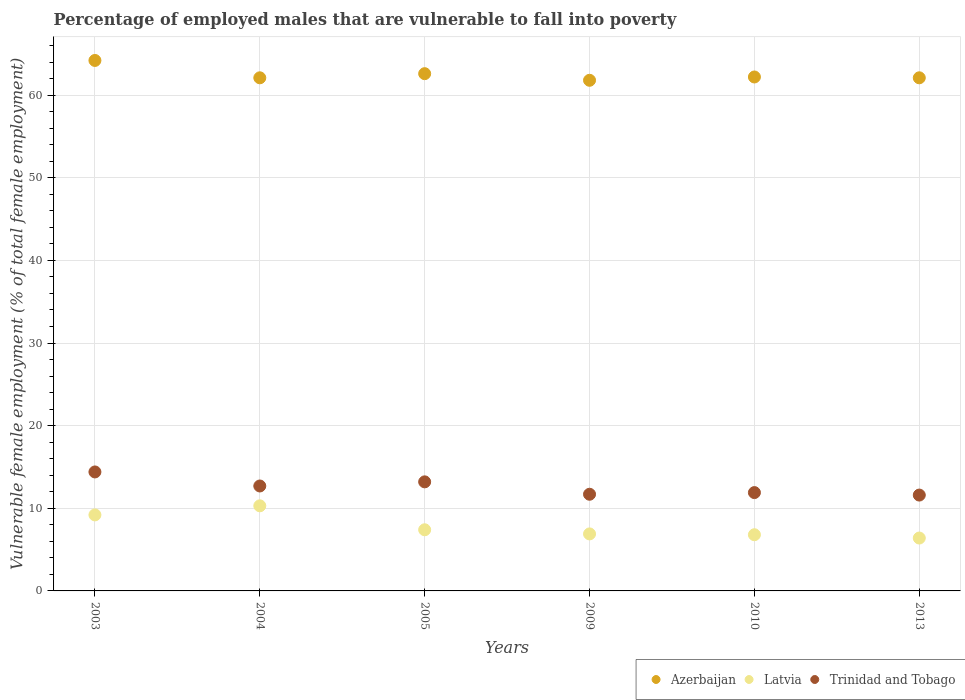How many different coloured dotlines are there?
Make the answer very short. 3. What is the percentage of employed males who are vulnerable to fall into poverty in Trinidad and Tobago in 2003?
Give a very brief answer. 14.4. Across all years, what is the maximum percentage of employed males who are vulnerable to fall into poverty in Azerbaijan?
Your answer should be compact. 64.2. Across all years, what is the minimum percentage of employed males who are vulnerable to fall into poverty in Trinidad and Tobago?
Offer a very short reply. 11.6. In which year was the percentage of employed males who are vulnerable to fall into poverty in Latvia maximum?
Your response must be concise. 2004. What is the total percentage of employed males who are vulnerable to fall into poverty in Latvia in the graph?
Your answer should be very brief. 47. What is the difference between the percentage of employed males who are vulnerable to fall into poverty in Trinidad and Tobago in 2009 and that in 2013?
Your answer should be compact. 0.1. What is the difference between the percentage of employed males who are vulnerable to fall into poverty in Latvia in 2004 and the percentage of employed males who are vulnerable to fall into poverty in Trinidad and Tobago in 2013?
Your response must be concise. -1.3. What is the average percentage of employed males who are vulnerable to fall into poverty in Azerbaijan per year?
Give a very brief answer. 62.5. In the year 2010, what is the difference between the percentage of employed males who are vulnerable to fall into poverty in Trinidad and Tobago and percentage of employed males who are vulnerable to fall into poverty in Azerbaijan?
Your answer should be very brief. -50.3. In how many years, is the percentage of employed males who are vulnerable to fall into poverty in Azerbaijan greater than 10 %?
Offer a terse response. 6. What is the ratio of the percentage of employed males who are vulnerable to fall into poverty in Latvia in 2005 to that in 2013?
Offer a terse response. 1.16. Is the difference between the percentage of employed males who are vulnerable to fall into poverty in Trinidad and Tobago in 2009 and 2013 greater than the difference between the percentage of employed males who are vulnerable to fall into poverty in Azerbaijan in 2009 and 2013?
Ensure brevity in your answer.  Yes. What is the difference between the highest and the second highest percentage of employed males who are vulnerable to fall into poverty in Latvia?
Make the answer very short. 1.1. What is the difference between the highest and the lowest percentage of employed males who are vulnerable to fall into poverty in Latvia?
Keep it short and to the point. 3.9. Is the sum of the percentage of employed males who are vulnerable to fall into poverty in Trinidad and Tobago in 2004 and 2009 greater than the maximum percentage of employed males who are vulnerable to fall into poverty in Latvia across all years?
Offer a very short reply. Yes. Is it the case that in every year, the sum of the percentage of employed males who are vulnerable to fall into poverty in Azerbaijan and percentage of employed males who are vulnerable to fall into poverty in Latvia  is greater than the percentage of employed males who are vulnerable to fall into poverty in Trinidad and Tobago?
Make the answer very short. Yes. Does the percentage of employed males who are vulnerable to fall into poverty in Latvia monotonically increase over the years?
Provide a succinct answer. No. Is the percentage of employed males who are vulnerable to fall into poverty in Trinidad and Tobago strictly greater than the percentage of employed males who are vulnerable to fall into poverty in Azerbaijan over the years?
Offer a very short reply. No. How many dotlines are there?
Offer a very short reply. 3. What is the difference between two consecutive major ticks on the Y-axis?
Give a very brief answer. 10. Does the graph contain any zero values?
Make the answer very short. No. Does the graph contain grids?
Offer a very short reply. Yes. What is the title of the graph?
Your answer should be very brief. Percentage of employed males that are vulnerable to fall into poverty. Does "East Asia (all income levels)" appear as one of the legend labels in the graph?
Provide a succinct answer. No. What is the label or title of the X-axis?
Offer a terse response. Years. What is the label or title of the Y-axis?
Offer a very short reply. Vulnerable female employment (% of total female employment). What is the Vulnerable female employment (% of total female employment) in Azerbaijan in 2003?
Provide a succinct answer. 64.2. What is the Vulnerable female employment (% of total female employment) of Latvia in 2003?
Provide a succinct answer. 9.2. What is the Vulnerable female employment (% of total female employment) in Trinidad and Tobago in 2003?
Your answer should be compact. 14.4. What is the Vulnerable female employment (% of total female employment) of Azerbaijan in 2004?
Your answer should be compact. 62.1. What is the Vulnerable female employment (% of total female employment) of Latvia in 2004?
Ensure brevity in your answer.  10.3. What is the Vulnerable female employment (% of total female employment) in Trinidad and Tobago in 2004?
Offer a very short reply. 12.7. What is the Vulnerable female employment (% of total female employment) in Azerbaijan in 2005?
Offer a very short reply. 62.6. What is the Vulnerable female employment (% of total female employment) in Latvia in 2005?
Keep it short and to the point. 7.4. What is the Vulnerable female employment (% of total female employment) in Trinidad and Tobago in 2005?
Make the answer very short. 13.2. What is the Vulnerable female employment (% of total female employment) in Azerbaijan in 2009?
Give a very brief answer. 61.8. What is the Vulnerable female employment (% of total female employment) of Latvia in 2009?
Offer a terse response. 6.9. What is the Vulnerable female employment (% of total female employment) of Trinidad and Tobago in 2009?
Provide a short and direct response. 11.7. What is the Vulnerable female employment (% of total female employment) of Azerbaijan in 2010?
Provide a short and direct response. 62.2. What is the Vulnerable female employment (% of total female employment) of Latvia in 2010?
Give a very brief answer. 6.8. What is the Vulnerable female employment (% of total female employment) in Trinidad and Tobago in 2010?
Your answer should be compact. 11.9. What is the Vulnerable female employment (% of total female employment) in Azerbaijan in 2013?
Ensure brevity in your answer.  62.1. What is the Vulnerable female employment (% of total female employment) in Latvia in 2013?
Offer a terse response. 6.4. What is the Vulnerable female employment (% of total female employment) in Trinidad and Tobago in 2013?
Provide a short and direct response. 11.6. Across all years, what is the maximum Vulnerable female employment (% of total female employment) in Azerbaijan?
Offer a terse response. 64.2. Across all years, what is the maximum Vulnerable female employment (% of total female employment) in Latvia?
Your answer should be very brief. 10.3. Across all years, what is the maximum Vulnerable female employment (% of total female employment) of Trinidad and Tobago?
Provide a short and direct response. 14.4. Across all years, what is the minimum Vulnerable female employment (% of total female employment) of Azerbaijan?
Give a very brief answer. 61.8. Across all years, what is the minimum Vulnerable female employment (% of total female employment) in Latvia?
Your answer should be very brief. 6.4. Across all years, what is the minimum Vulnerable female employment (% of total female employment) in Trinidad and Tobago?
Offer a terse response. 11.6. What is the total Vulnerable female employment (% of total female employment) of Azerbaijan in the graph?
Your answer should be very brief. 375. What is the total Vulnerable female employment (% of total female employment) of Trinidad and Tobago in the graph?
Offer a terse response. 75.5. What is the difference between the Vulnerable female employment (% of total female employment) of Latvia in 2003 and that in 2004?
Give a very brief answer. -1.1. What is the difference between the Vulnerable female employment (% of total female employment) in Azerbaijan in 2003 and that in 2005?
Give a very brief answer. 1.6. What is the difference between the Vulnerable female employment (% of total female employment) of Latvia in 2003 and that in 2009?
Keep it short and to the point. 2.3. What is the difference between the Vulnerable female employment (% of total female employment) of Azerbaijan in 2003 and that in 2010?
Offer a terse response. 2. What is the difference between the Vulnerable female employment (% of total female employment) in Latvia in 2003 and that in 2010?
Your answer should be very brief. 2.4. What is the difference between the Vulnerable female employment (% of total female employment) of Trinidad and Tobago in 2003 and that in 2010?
Provide a succinct answer. 2.5. What is the difference between the Vulnerable female employment (% of total female employment) of Azerbaijan in 2003 and that in 2013?
Keep it short and to the point. 2.1. What is the difference between the Vulnerable female employment (% of total female employment) of Latvia in 2003 and that in 2013?
Make the answer very short. 2.8. What is the difference between the Vulnerable female employment (% of total female employment) of Azerbaijan in 2004 and that in 2005?
Your response must be concise. -0.5. What is the difference between the Vulnerable female employment (% of total female employment) in Azerbaijan in 2004 and that in 2009?
Your answer should be very brief. 0.3. What is the difference between the Vulnerable female employment (% of total female employment) of Latvia in 2004 and that in 2009?
Make the answer very short. 3.4. What is the difference between the Vulnerable female employment (% of total female employment) in Trinidad and Tobago in 2004 and that in 2009?
Ensure brevity in your answer.  1. What is the difference between the Vulnerable female employment (% of total female employment) in Azerbaijan in 2004 and that in 2010?
Make the answer very short. -0.1. What is the difference between the Vulnerable female employment (% of total female employment) in Azerbaijan in 2004 and that in 2013?
Ensure brevity in your answer.  0. What is the difference between the Vulnerable female employment (% of total female employment) in Latvia in 2004 and that in 2013?
Offer a very short reply. 3.9. What is the difference between the Vulnerable female employment (% of total female employment) of Latvia in 2005 and that in 2010?
Ensure brevity in your answer.  0.6. What is the difference between the Vulnerable female employment (% of total female employment) of Latvia in 2005 and that in 2013?
Offer a terse response. 1. What is the difference between the Vulnerable female employment (% of total female employment) in Azerbaijan in 2009 and that in 2010?
Your answer should be compact. -0.4. What is the difference between the Vulnerable female employment (% of total female employment) in Trinidad and Tobago in 2009 and that in 2010?
Make the answer very short. -0.2. What is the difference between the Vulnerable female employment (% of total female employment) of Latvia in 2009 and that in 2013?
Provide a short and direct response. 0.5. What is the difference between the Vulnerable female employment (% of total female employment) of Trinidad and Tobago in 2009 and that in 2013?
Your response must be concise. 0.1. What is the difference between the Vulnerable female employment (% of total female employment) in Latvia in 2010 and that in 2013?
Your answer should be compact. 0.4. What is the difference between the Vulnerable female employment (% of total female employment) of Trinidad and Tobago in 2010 and that in 2013?
Make the answer very short. 0.3. What is the difference between the Vulnerable female employment (% of total female employment) in Azerbaijan in 2003 and the Vulnerable female employment (% of total female employment) in Latvia in 2004?
Keep it short and to the point. 53.9. What is the difference between the Vulnerable female employment (% of total female employment) in Azerbaijan in 2003 and the Vulnerable female employment (% of total female employment) in Trinidad and Tobago in 2004?
Make the answer very short. 51.5. What is the difference between the Vulnerable female employment (% of total female employment) in Latvia in 2003 and the Vulnerable female employment (% of total female employment) in Trinidad and Tobago in 2004?
Ensure brevity in your answer.  -3.5. What is the difference between the Vulnerable female employment (% of total female employment) in Azerbaijan in 2003 and the Vulnerable female employment (% of total female employment) in Latvia in 2005?
Make the answer very short. 56.8. What is the difference between the Vulnerable female employment (% of total female employment) in Azerbaijan in 2003 and the Vulnerable female employment (% of total female employment) in Latvia in 2009?
Keep it short and to the point. 57.3. What is the difference between the Vulnerable female employment (% of total female employment) in Azerbaijan in 2003 and the Vulnerable female employment (% of total female employment) in Trinidad and Tobago in 2009?
Ensure brevity in your answer.  52.5. What is the difference between the Vulnerable female employment (% of total female employment) in Azerbaijan in 2003 and the Vulnerable female employment (% of total female employment) in Latvia in 2010?
Provide a succinct answer. 57.4. What is the difference between the Vulnerable female employment (% of total female employment) in Azerbaijan in 2003 and the Vulnerable female employment (% of total female employment) in Trinidad and Tobago in 2010?
Make the answer very short. 52.3. What is the difference between the Vulnerable female employment (% of total female employment) of Latvia in 2003 and the Vulnerable female employment (% of total female employment) of Trinidad and Tobago in 2010?
Offer a very short reply. -2.7. What is the difference between the Vulnerable female employment (% of total female employment) in Azerbaijan in 2003 and the Vulnerable female employment (% of total female employment) in Latvia in 2013?
Make the answer very short. 57.8. What is the difference between the Vulnerable female employment (% of total female employment) of Azerbaijan in 2003 and the Vulnerable female employment (% of total female employment) of Trinidad and Tobago in 2013?
Offer a terse response. 52.6. What is the difference between the Vulnerable female employment (% of total female employment) of Latvia in 2003 and the Vulnerable female employment (% of total female employment) of Trinidad and Tobago in 2013?
Ensure brevity in your answer.  -2.4. What is the difference between the Vulnerable female employment (% of total female employment) of Azerbaijan in 2004 and the Vulnerable female employment (% of total female employment) of Latvia in 2005?
Provide a short and direct response. 54.7. What is the difference between the Vulnerable female employment (% of total female employment) of Azerbaijan in 2004 and the Vulnerable female employment (% of total female employment) of Trinidad and Tobago in 2005?
Your response must be concise. 48.9. What is the difference between the Vulnerable female employment (% of total female employment) of Azerbaijan in 2004 and the Vulnerable female employment (% of total female employment) of Latvia in 2009?
Your answer should be very brief. 55.2. What is the difference between the Vulnerable female employment (% of total female employment) in Azerbaijan in 2004 and the Vulnerable female employment (% of total female employment) in Trinidad and Tobago in 2009?
Offer a very short reply. 50.4. What is the difference between the Vulnerable female employment (% of total female employment) of Latvia in 2004 and the Vulnerable female employment (% of total female employment) of Trinidad and Tobago in 2009?
Keep it short and to the point. -1.4. What is the difference between the Vulnerable female employment (% of total female employment) of Azerbaijan in 2004 and the Vulnerable female employment (% of total female employment) of Latvia in 2010?
Provide a succinct answer. 55.3. What is the difference between the Vulnerable female employment (% of total female employment) of Azerbaijan in 2004 and the Vulnerable female employment (% of total female employment) of Trinidad and Tobago in 2010?
Ensure brevity in your answer.  50.2. What is the difference between the Vulnerable female employment (% of total female employment) of Latvia in 2004 and the Vulnerable female employment (% of total female employment) of Trinidad and Tobago in 2010?
Provide a short and direct response. -1.6. What is the difference between the Vulnerable female employment (% of total female employment) of Azerbaijan in 2004 and the Vulnerable female employment (% of total female employment) of Latvia in 2013?
Provide a short and direct response. 55.7. What is the difference between the Vulnerable female employment (% of total female employment) in Azerbaijan in 2004 and the Vulnerable female employment (% of total female employment) in Trinidad and Tobago in 2013?
Make the answer very short. 50.5. What is the difference between the Vulnerable female employment (% of total female employment) in Latvia in 2004 and the Vulnerable female employment (% of total female employment) in Trinidad and Tobago in 2013?
Provide a succinct answer. -1.3. What is the difference between the Vulnerable female employment (% of total female employment) of Azerbaijan in 2005 and the Vulnerable female employment (% of total female employment) of Latvia in 2009?
Your answer should be compact. 55.7. What is the difference between the Vulnerable female employment (% of total female employment) of Azerbaijan in 2005 and the Vulnerable female employment (% of total female employment) of Trinidad and Tobago in 2009?
Make the answer very short. 50.9. What is the difference between the Vulnerable female employment (% of total female employment) in Azerbaijan in 2005 and the Vulnerable female employment (% of total female employment) in Latvia in 2010?
Provide a short and direct response. 55.8. What is the difference between the Vulnerable female employment (% of total female employment) of Azerbaijan in 2005 and the Vulnerable female employment (% of total female employment) of Trinidad and Tobago in 2010?
Make the answer very short. 50.7. What is the difference between the Vulnerable female employment (% of total female employment) in Latvia in 2005 and the Vulnerable female employment (% of total female employment) in Trinidad and Tobago in 2010?
Make the answer very short. -4.5. What is the difference between the Vulnerable female employment (% of total female employment) in Azerbaijan in 2005 and the Vulnerable female employment (% of total female employment) in Latvia in 2013?
Keep it short and to the point. 56.2. What is the difference between the Vulnerable female employment (% of total female employment) in Latvia in 2005 and the Vulnerable female employment (% of total female employment) in Trinidad and Tobago in 2013?
Give a very brief answer. -4.2. What is the difference between the Vulnerable female employment (% of total female employment) of Azerbaijan in 2009 and the Vulnerable female employment (% of total female employment) of Trinidad and Tobago in 2010?
Make the answer very short. 49.9. What is the difference between the Vulnerable female employment (% of total female employment) of Azerbaijan in 2009 and the Vulnerable female employment (% of total female employment) of Latvia in 2013?
Your response must be concise. 55.4. What is the difference between the Vulnerable female employment (% of total female employment) in Azerbaijan in 2009 and the Vulnerable female employment (% of total female employment) in Trinidad and Tobago in 2013?
Ensure brevity in your answer.  50.2. What is the difference between the Vulnerable female employment (% of total female employment) of Azerbaijan in 2010 and the Vulnerable female employment (% of total female employment) of Latvia in 2013?
Ensure brevity in your answer.  55.8. What is the difference between the Vulnerable female employment (% of total female employment) in Azerbaijan in 2010 and the Vulnerable female employment (% of total female employment) in Trinidad and Tobago in 2013?
Keep it short and to the point. 50.6. What is the difference between the Vulnerable female employment (% of total female employment) of Latvia in 2010 and the Vulnerable female employment (% of total female employment) of Trinidad and Tobago in 2013?
Offer a terse response. -4.8. What is the average Vulnerable female employment (% of total female employment) in Azerbaijan per year?
Provide a succinct answer. 62.5. What is the average Vulnerable female employment (% of total female employment) in Latvia per year?
Make the answer very short. 7.83. What is the average Vulnerable female employment (% of total female employment) of Trinidad and Tobago per year?
Keep it short and to the point. 12.58. In the year 2003, what is the difference between the Vulnerable female employment (% of total female employment) in Azerbaijan and Vulnerable female employment (% of total female employment) in Trinidad and Tobago?
Offer a very short reply. 49.8. In the year 2004, what is the difference between the Vulnerable female employment (% of total female employment) of Azerbaijan and Vulnerable female employment (% of total female employment) of Latvia?
Ensure brevity in your answer.  51.8. In the year 2004, what is the difference between the Vulnerable female employment (% of total female employment) of Azerbaijan and Vulnerable female employment (% of total female employment) of Trinidad and Tobago?
Provide a short and direct response. 49.4. In the year 2005, what is the difference between the Vulnerable female employment (% of total female employment) in Azerbaijan and Vulnerable female employment (% of total female employment) in Latvia?
Provide a succinct answer. 55.2. In the year 2005, what is the difference between the Vulnerable female employment (% of total female employment) of Azerbaijan and Vulnerable female employment (% of total female employment) of Trinidad and Tobago?
Provide a short and direct response. 49.4. In the year 2005, what is the difference between the Vulnerable female employment (% of total female employment) in Latvia and Vulnerable female employment (% of total female employment) in Trinidad and Tobago?
Keep it short and to the point. -5.8. In the year 2009, what is the difference between the Vulnerable female employment (% of total female employment) in Azerbaijan and Vulnerable female employment (% of total female employment) in Latvia?
Provide a short and direct response. 54.9. In the year 2009, what is the difference between the Vulnerable female employment (% of total female employment) of Azerbaijan and Vulnerable female employment (% of total female employment) of Trinidad and Tobago?
Keep it short and to the point. 50.1. In the year 2010, what is the difference between the Vulnerable female employment (% of total female employment) of Azerbaijan and Vulnerable female employment (% of total female employment) of Latvia?
Your response must be concise. 55.4. In the year 2010, what is the difference between the Vulnerable female employment (% of total female employment) of Azerbaijan and Vulnerable female employment (% of total female employment) of Trinidad and Tobago?
Keep it short and to the point. 50.3. In the year 2010, what is the difference between the Vulnerable female employment (% of total female employment) of Latvia and Vulnerable female employment (% of total female employment) of Trinidad and Tobago?
Ensure brevity in your answer.  -5.1. In the year 2013, what is the difference between the Vulnerable female employment (% of total female employment) of Azerbaijan and Vulnerable female employment (% of total female employment) of Latvia?
Keep it short and to the point. 55.7. In the year 2013, what is the difference between the Vulnerable female employment (% of total female employment) of Azerbaijan and Vulnerable female employment (% of total female employment) of Trinidad and Tobago?
Your response must be concise. 50.5. In the year 2013, what is the difference between the Vulnerable female employment (% of total female employment) in Latvia and Vulnerable female employment (% of total female employment) in Trinidad and Tobago?
Ensure brevity in your answer.  -5.2. What is the ratio of the Vulnerable female employment (% of total female employment) of Azerbaijan in 2003 to that in 2004?
Keep it short and to the point. 1.03. What is the ratio of the Vulnerable female employment (% of total female employment) in Latvia in 2003 to that in 2004?
Offer a very short reply. 0.89. What is the ratio of the Vulnerable female employment (% of total female employment) in Trinidad and Tobago in 2003 to that in 2004?
Provide a succinct answer. 1.13. What is the ratio of the Vulnerable female employment (% of total female employment) of Azerbaijan in 2003 to that in 2005?
Offer a very short reply. 1.03. What is the ratio of the Vulnerable female employment (% of total female employment) in Latvia in 2003 to that in 2005?
Offer a very short reply. 1.24. What is the ratio of the Vulnerable female employment (% of total female employment) in Trinidad and Tobago in 2003 to that in 2005?
Your response must be concise. 1.09. What is the ratio of the Vulnerable female employment (% of total female employment) in Azerbaijan in 2003 to that in 2009?
Provide a short and direct response. 1.04. What is the ratio of the Vulnerable female employment (% of total female employment) in Latvia in 2003 to that in 2009?
Keep it short and to the point. 1.33. What is the ratio of the Vulnerable female employment (% of total female employment) of Trinidad and Tobago in 2003 to that in 2009?
Provide a succinct answer. 1.23. What is the ratio of the Vulnerable female employment (% of total female employment) in Azerbaijan in 2003 to that in 2010?
Offer a very short reply. 1.03. What is the ratio of the Vulnerable female employment (% of total female employment) in Latvia in 2003 to that in 2010?
Offer a very short reply. 1.35. What is the ratio of the Vulnerable female employment (% of total female employment) of Trinidad and Tobago in 2003 to that in 2010?
Offer a very short reply. 1.21. What is the ratio of the Vulnerable female employment (% of total female employment) of Azerbaijan in 2003 to that in 2013?
Your response must be concise. 1.03. What is the ratio of the Vulnerable female employment (% of total female employment) in Latvia in 2003 to that in 2013?
Provide a short and direct response. 1.44. What is the ratio of the Vulnerable female employment (% of total female employment) of Trinidad and Tobago in 2003 to that in 2013?
Provide a short and direct response. 1.24. What is the ratio of the Vulnerable female employment (% of total female employment) of Azerbaijan in 2004 to that in 2005?
Give a very brief answer. 0.99. What is the ratio of the Vulnerable female employment (% of total female employment) in Latvia in 2004 to that in 2005?
Keep it short and to the point. 1.39. What is the ratio of the Vulnerable female employment (% of total female employment) of Trinidad and Tobago in 2004 to that in 2005?
Make the answer very short. 0.96. What is the ratio of the Vulnerable female employment (% of total female employment) of Latvia in 2004 to that in 2009?
Your answer should be compact. 1.49. What is the ratio of the Vulnerable female employment (% of total female employment) in Trinidad and Tobago in 2004 to that in 2009?
Keep it short and to the point. 1.09. What is the ratio of the Vulnerable female employment (% of total female employment) in Latvia in 2004 to that in 2010?
Provide a short and direct response. 1.51. What is the ratio of the Vulnerable female employment (% of total female employment) of Trinidad and Tobago in 2004 to that in 2010?
Your response must be concise. 1.07. What is the ratio of the Vulnerable female employment (% of total female employment) of Latvia in 2004 to that in 2013?
Provide a succinct answer. 1.61. What is the ratio of the Vulnerable female employment (% of total female employment) of Trinidad and Tobago in 2004 to that in 2013?
Ensure brevity in your answer.  1.09. What is the ratio of the Vulnerable female employment (% of total female employment) of Azerbaijan in 2005 to that in 2009?
Make the answer very short. 1.01. What is the ratio of the Vulnerable female employment (% of total female employment) in Latvia in 2005 to that in 2009?
Your answer should be compact. 1.07. What is the ratio of the Vulnerable female employment (% of total female employment) in Trinidad and Tobago in 2005 to that in 2009?
Offer a very short reply. 1.13. What is the ratio of the Vulnerable female employment (% of total female employment) in Azerbaijan in 2005 to that in 2010?
Keep it short and to the point. 1.01. What is the ratio of the Vulnerable female employment (% of total female employment) in Latvia in 2005 to that in 2010?
Ensure brevity in your answer.  1.09. What is the ratio of the Vulnerable female employment (% of total female employment) of Trinidad and Tobago in 2005 to that in 2010?
Offer a very short reply. 1.11. What is the ratio of the Vulnerable female employment (% of total female employment) in Azerbaijan in 2005 to that in 2013?
Provide a short and direct response. 1.01. What is the ratio of the Vulnerable female employment (% of total female employment) in Latvia in 2005 to that in 2013?
Ensure brevity in your answer.  1.16. What is the ratio of the Vulnerable female employment (% of total female employment) in Trinidad and Tobago in 2005 to that in 2013?
Your response must be concise. 1.14. What is the ratio of the Vulnerable female employment (% of total female employment) of Latvia in 2009 to that in 2010?
Provide a succinct answer. 1.01. What is the ratio of the Vulnerable female employment (% of total female employment) of Trinidad and Tobago in 2009 to that in 2010?
Provide a short and direct response. 0.98. What is the ratio of the Vulnerable female employment (% of total female employment) of Azerbaijan in 2009 to that in 2013?
Provide a succinct answer. 1. What is the ratio of the Vulnerable female employment (% of total female employment) of Latvia in 2009 to that in 2013?
Offer a very short reply. 1.08. What is the ratio of the Vulnerable female employment (% of total female employment) of Trinidad and Tobago in 2009 to that in 2013?
Give a very brief answer. 1.01. What is the ratio of the Vulnerable female employment (% of total female employment) of Trinidad and Tobago in 2010 to that in 2013?
Provide a succinct answer. 1.03. What is the difference between the highest and the second highest Vulnerable female employment (% of total female employment) in Azerbaijan?
Your answer should be compact. 1.6. What is the difference between the highest and the second highest Vulnerable female employment (% of total female employment) in Latvia?
Keep it short and to the point. 1.1. What is the difference between the highest and the second highest Vulnerable female employment (% of total female employment) in Trinidad and Tobago?
Ensure brevity in your answer.  1.2. What is the difference between the highest and the lowest Vulnerable female employment (% of total female employment) of Latvia?
Ensure brevity in your answer.  3.9. 